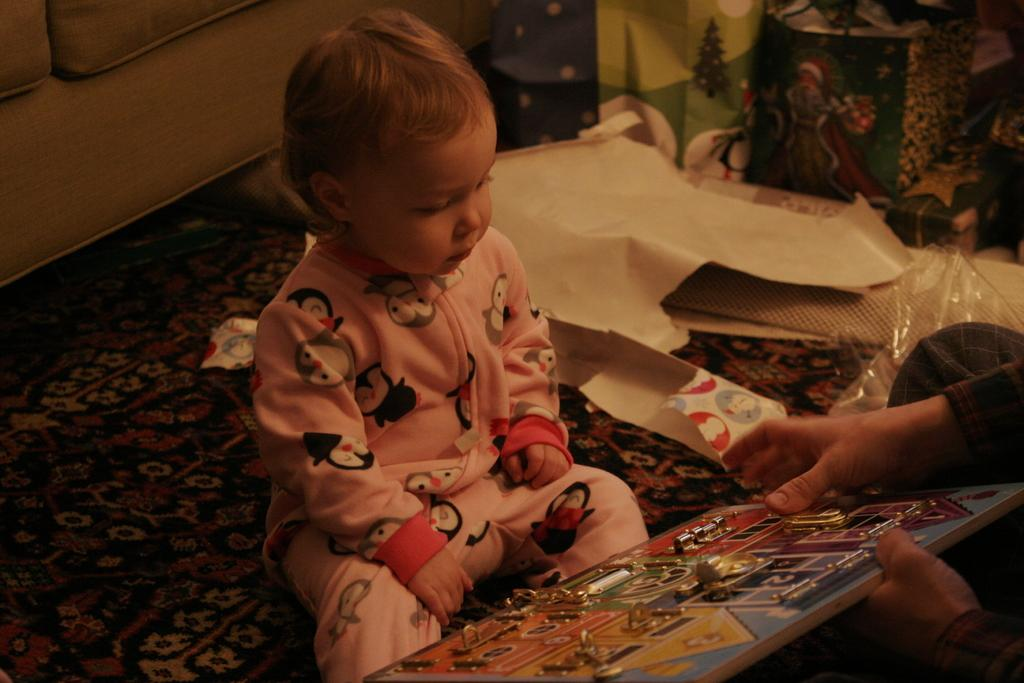What is the main subject of the image? There is a kid in the image. What is the person holding in the image? There is a person holding an object in the image. What type of furniture can be seen in the background of the image? There is a sofa in the background of the image. What items are visible in the background of the image? There are bags visible in the background of the image. What type of flooring is at the bottom of the image? There is a carpet at the bottom of the image. What type of cracker is the kid eating in the image? There is no cracker present in the image, and the kid is not eating anything. Can you tell me how many experts are present in the image? There are no experts present in the image; it features a kid and a person holding an object. 